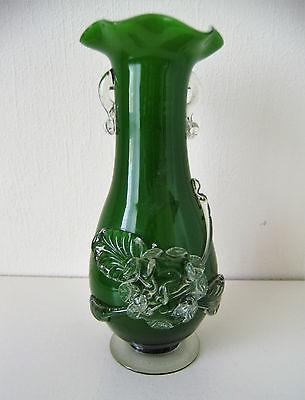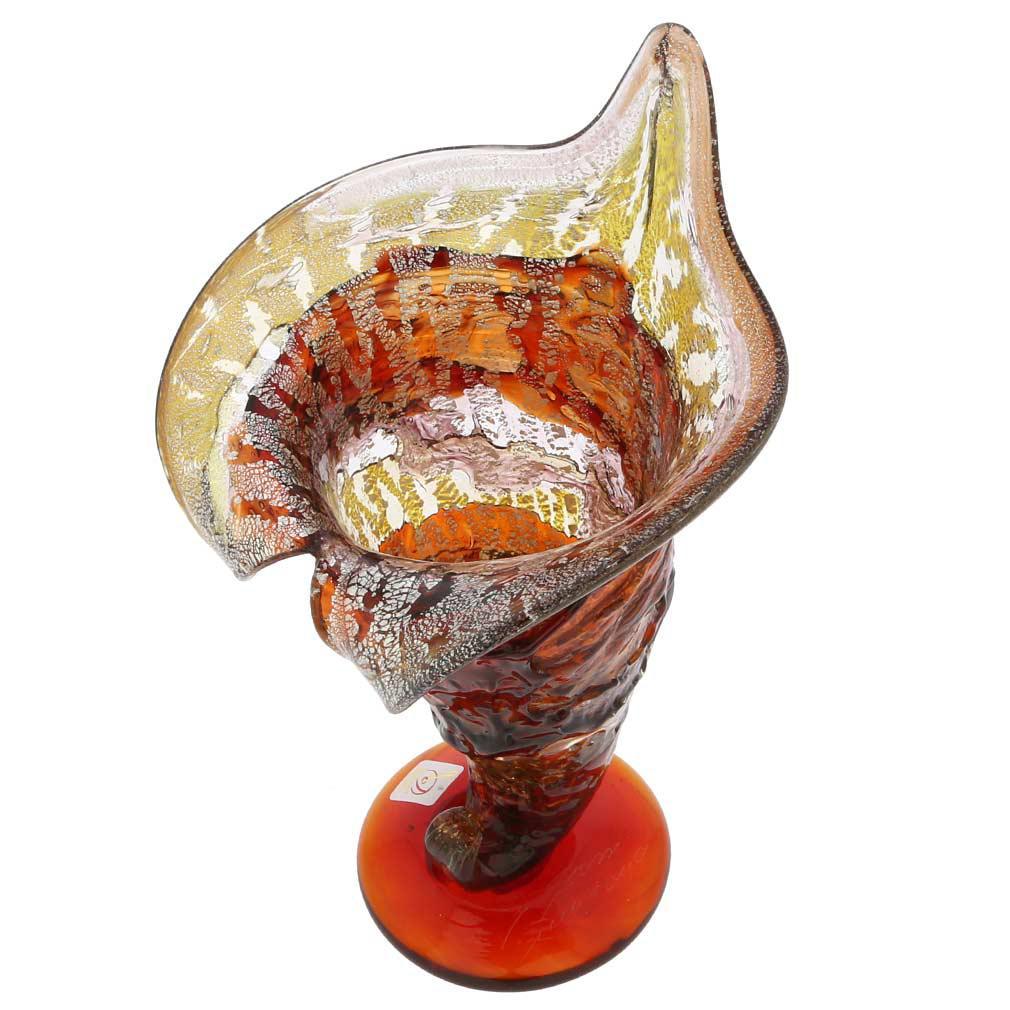The first image is the image on the left, the second image is the image on the right. Analyze the images presented: Is the assertion "The vases in the two images have the same shape and color." valid? Answer yes or no. No. 